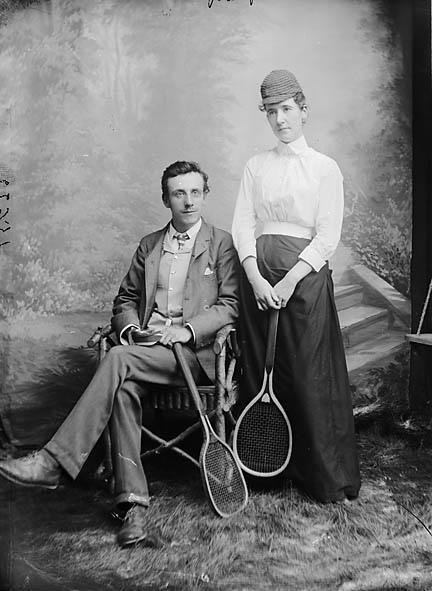How many people are there?
Give a very brief answer. 2. How many tennis rackets are in the picture?
Give a very brief answer. 2. How many orange cones can be seen?
Give a very brief answer. 0. 